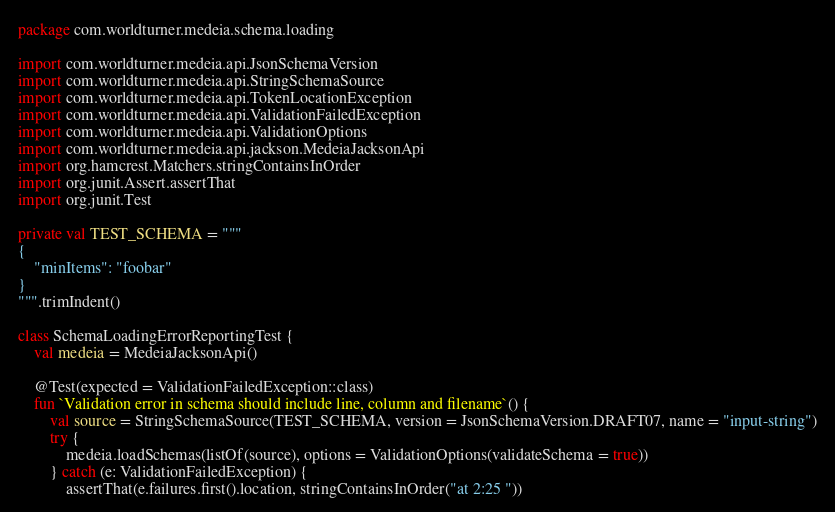Convert code to text. <code><loc_0><loc_0><loc_500><loc_500><_Kotlin_>package com.worldturner.medeia.schema.loading

import com.worldturner.medeia.api.JsonSchemaVersion
import com.worldturner.medeia.api.StringSchemaSource
import com.worldturner.medeia.api.TokenLocationException
import com.worldturner.medeia.api.ValidationFailedException
import com.worldturner.medeia.api.ValidationOptions
import com.worldturner.medeia.api.jackson.MedeiaJacksonApi
import org.hamcrest.Matchers.stringContainsInOrder
import org.junit.Assert.assertThat
import org.junit.Test

private val TEST_SCHEMA = """
{
    "minItems": "foobar"
}
""".trimIndent()

class SchemaLoadingErrorReportingTest {
    val medeia = MedeiaJacksonApi()

    @Test(expected = ValidationFailedException::class)
    fun `Validation error in schema should include line, column and filename`() {
        val source = StringSchemaSource(TEST_SCHEMA, version = JsonSchemaVersion.DRAFT07, name = "input-string")
        try {
            medeia.loadSchemas(listOf(source), options = ValidationOptions(validateSchema = true))
        } catch (e: ValidationFailedException) {
            assertThat(e.failures.first().location, stringContainsInOrder("at 2:25 "))</code> 